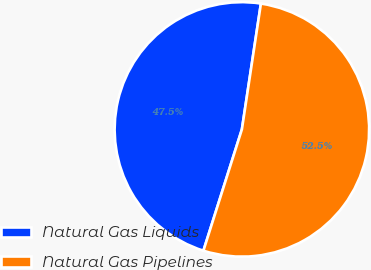Convert chart. <chart><loc_0><loc_0><loc_500><loc_500><pie_chart><fcel>Natural Gas Liquids<fcel>Natural Gas Pipelines<nl><fcel>47.5%<fcel>52.5%<nl></chart> 